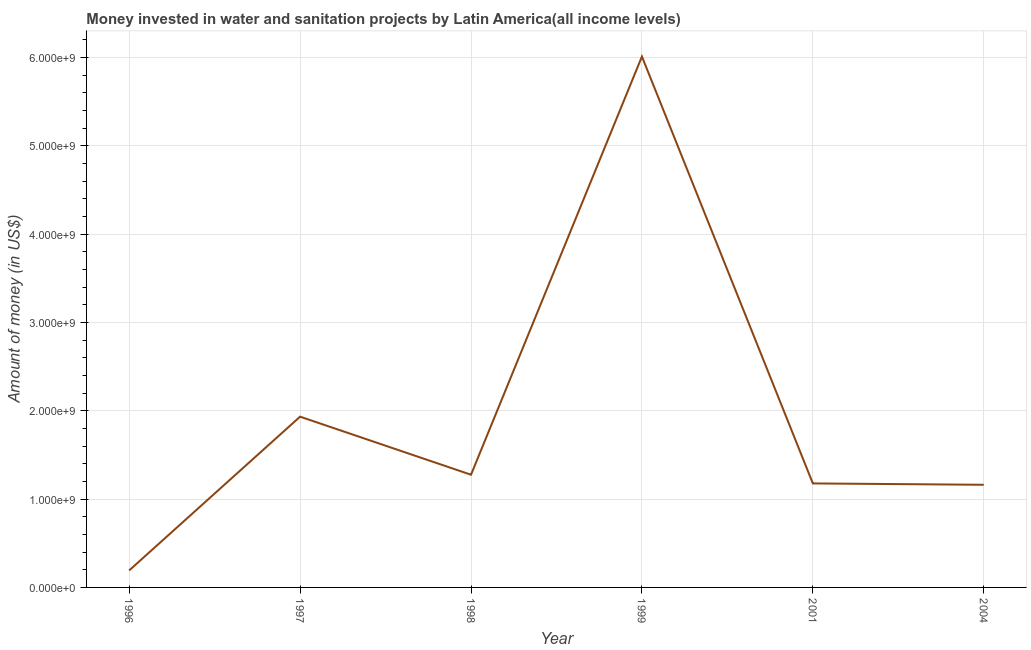What is the investment in 2001?
Make the answer very short. 1.18e+09. Across all years, what is the maximum investment?
Provide a succinct answer. 6.01e+09. Across all years, what is the minimum investment?
Offer a very short reply. 1.92e+08. In which year was the investment minimum?
Your answer should be very brief. 1996. What is the sum of the investment?
Provide a succinct answer. 1.18e+1. What is the difference between the investment in 1997 and 1998?
Make the answer very short. 6.57e+08. What is the average investment per year?
Your answer should be compact. 1.96e+09. What is the median investment?
Your response must be concise. 1.23e+09. In how many years, is the investment greater than 2200000000 US$?
Provide a short and direct response. 1. What is the ratio of the investment in 1999 to that in 2001?
Ensure brevity in your answer.  5.1. What is the difference between the highest and the second highest investment?
Your response must be concise. 4.08e+09. Is the sum of the investment in 1997 and 2001 greater than the maximum investment across all years?
Ensure brevity in your answer.  No. What is the difference between the highest and the lowest investment?
Give a very brief answer. 5.82e+09. In how many years, is the investment greater than the average investment taken over all years?
Offer a terse response. 1. Does the investment monotonically increase over the years?
Ensure brevity in your answer.  No. How many lines are there?
Give a very brief answer. 1. Are the values on the major ticks of Y-axis written in scientific E-notation?
Provide a short and direct response. Yes. Does the graph contain grids?
Offer a very short reply. Yes. What is the title of the graph?
Your response must be concise. Money invested in water and sanitation projects by Latin America(all income levels). What is the label or title of the X-axis?
Your answer should be compact. Year. What is the label or title of the Y-axis?
Keep it short and to the point. Amount of money (in US$). What is the Amount of money (in US$) in 1996?
Keep it short and to the point. 1.92e+08. What is the Amount of money (in US$) of 1997?
Make the answer very short. 1.93e+09. What is the Amount of money (in US$) in 1998?
Make the answer very short. 1.28e+09. What is the Amount of money (in US$) of 1999?
Give a very brief answer. 6.01e+09. What is the Amount of money (in US$) in 2001?
Make the answer very short. 1.18e+09. What is the Amount of money (in US$) in 2004?
Give a very brief answer. 1.16e+09. What is the difference between the Amount of money (in US$) in 1996 and 1997?
Offer a terse response. -1.74e+09. What is the difference between the Amount of money (in US$) in 1996 and 1998?
Ensure brevity in your answer.  -1.08e+09. What is the difference between the Amount of money (in US$) in 1996 and 1999?
Make the answer very short. -5.82e+09. What is the difference between the Amount of money (in US$) in 1996 and 2001?
Provide a succinct answer. -9.85e+08. What is the difference between the Amount of money (in US$) in 1996 and 2004?
Ensure brevity in your answer.  -9.70e+08. What is the difference between the Amount of money (in US$) in 1997 and 1998?
Make the answer very short. 6.57e+08. What is the difference between the Amount of money (in US$) in 1997 and 1999?
Ensure brevity in your answer.  -4.08e+09. What is the difference between the Amount of money (in US$) in 1997 and 2001?
Provide a succinct answer. 7.56e+08. What is the difference between the Amount of money (in US$) in 1997 and 2004?
Keep it short and to the point. 7.71e+08. What is the difference between the Amount of money (in US$) in 1998 and 1999?
Ensure brevity in your answer.  -4.73e+09. What is the difference between the Amount of money (in US$) in 1998 and 2001?
Your answer should be compact. 9.85e+07. What is the difference between the Amount of money (in US$) in 1998 and 2004?
Offer a very short reply. 1.14e+08. What is the difference between the Amount of money (in US$) in 1999 and 2001?
Your answer should be very brief. 4.83e+09. What is the difference between the Amount of money (in US$) in 1999 and 2004?
Your response must be concise. 4.85e+09. What is the difference between the Amount of money (in US$) in 2001 and 2004?
Provide a short and direct response. 1.54e+07. What is the ratio of the Amount of money (in US$) in 1996 to that in 1997?
Offer a terse response. 0.1. What is the ratio of the Amount of money (in US$) in 1996 to that in 1998?
Your answer should be compact. 0.15. What is the ratio of the Amount of money (in US$) in 1996 to that in 1999?
Provide a succinct answer. 0.03. What is the ratio of the Amount of money (in US$) in 1996 to that in 2001?
Give a very brief answer. 0.16. What is the ratio of the Amount of money (in US$) in 1996 to that in 2004?
Ensure brevity in your answer.  0.17. What is the ratio of the Amount of money (in US$) in 1997 to that in 1998?
Make the answer very short. 1.51. What is the ratio of the Amount of money (in US$) in 1997 to that in 1999?
Give a very brief answer. 0.32. What is the ratio of the Amount of money (in US$) in 1997 to that in 2001?
Ensure brevity in your answer.  1.64. What is the ratio of the Amount of money (in US$) in 1997 to that in 2004?
Give a very brief answer. 1.66. What is the ratio of the Amount of money (in US$) in 1998 to that in 1999?
Your answer should be compact. 0.21. What is the ratio of the Amount of money (in US$) in 1998 to that in 2001?
Provide a short and direct response. 1.08. What is the ratio of the Amount of money (in US$) in 1998 to that in 2004?
Offer a terse response. 1.1. What is the ratio of the Amount of money (in US$) in 1999 to that in 2001?
Offer a terse response. 5.11. What is the ratio of the Amount of money (in US$) in 1999 to that in 2004?
Ensure brevity in your answer.  5.17. 